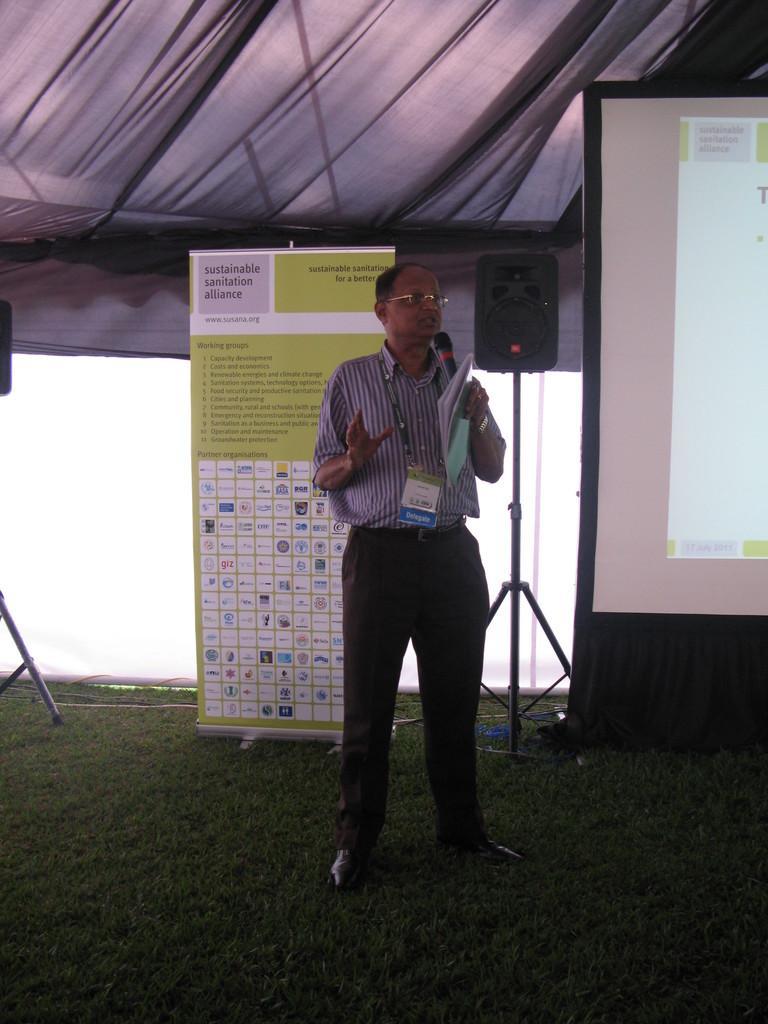Describe this image in one or two sentences. In this image I can see a person is standing and holding a microphone and a book in his hand. In the background I can see a projection screen, a banner, a speaker, some grass and the tent. 